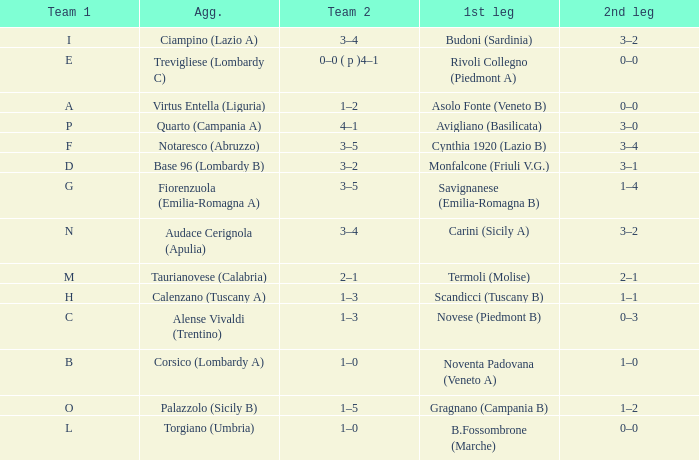What 1st leg has Alense Vivaldi (Trentino) as Agg.? Novese (Piedmont B). 